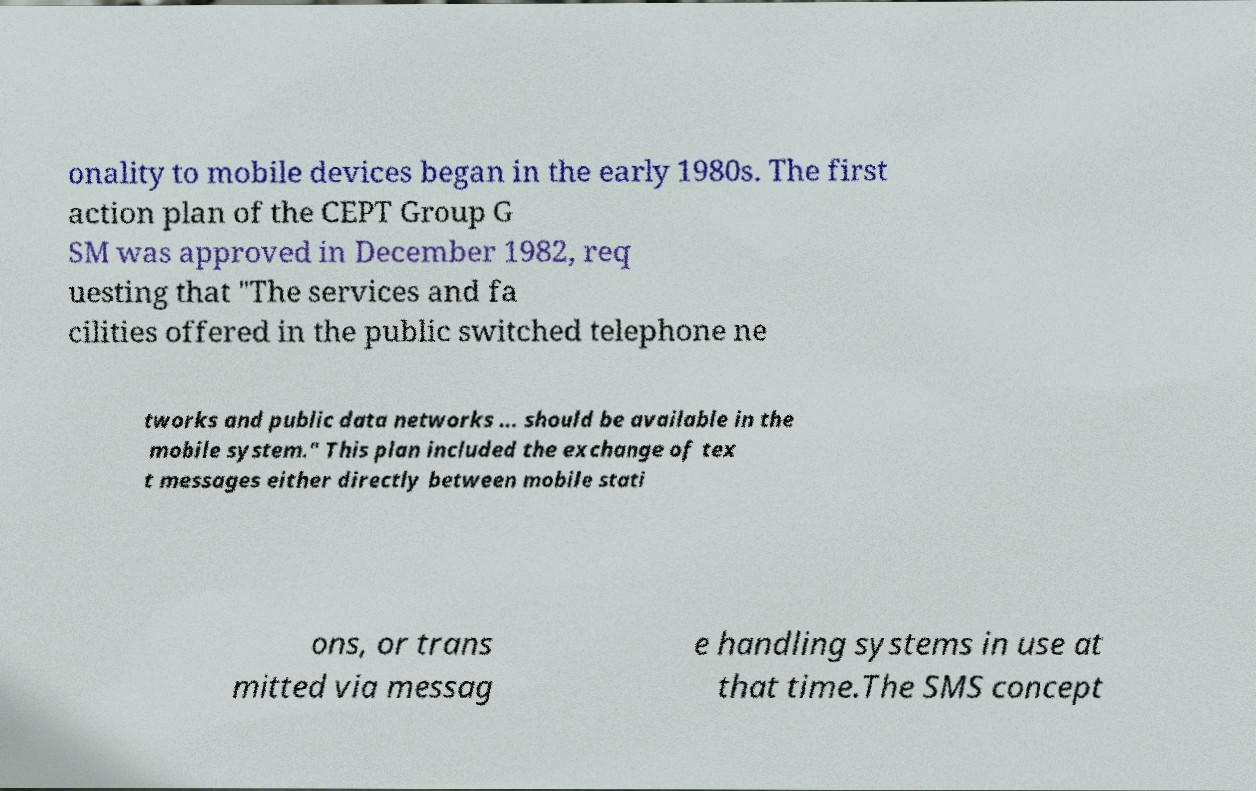For documentation purposes, I need the text within this image transcribed. Could you provide that? onality to mobile devices began in the early 1980s. The first action plan of the CEPT Group G SM was approved in December 1982, req uesting that "The services and fa cilities offered in the public switched telephone ne tworks and public data networks ... should be available in the mobile system." This plan included the exchange of tex t messages either directly between mobile stati ons, or trans mitted via messag e handling systems in use at that time.The SMS concept 